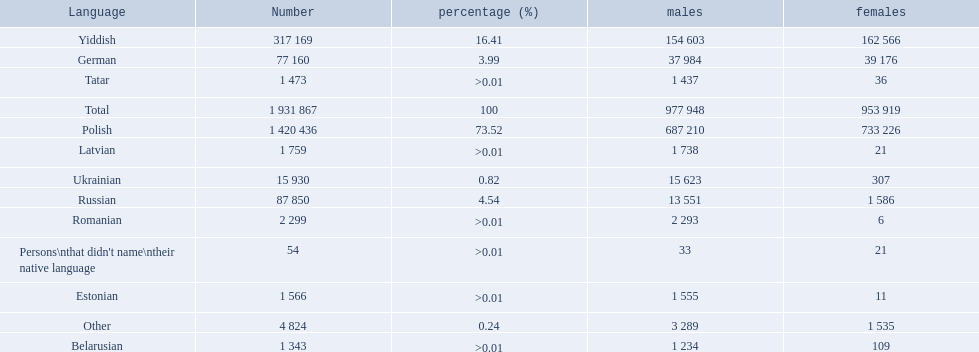Parse the full table in json format. {'header': ['Language', 'Number', 'percentage (%)', 'males', 'females'], 'rows': [['Yiddish', '317 169', '16.41', '154 603', '162 566'], ['German', '77 160', '3.99', '37 984', '39 176'], ['Tatar', '1 473', '>0.01', '1 437', '36'], ['Total', '1 931 867', '100', '977 948', '953 919'], ['Polish', '1 420 436', '73.52', '687 210', '733 226'], ['Latvian', '1 759', '>0.01', '1 738', '21'], ['Ukrainian', '15 930', '0.82', '15 623', '307'], ['Russian', '87 850', '4.54', '13 551', '1 586'], ['Romanian', '2 299', '>0.01', '2 293', '6'], ["Persons\\nthat didn't name\\ntheir native language", '54', '>0.01', '33', '21'], ['Estonian', '1 566', '>0.01', '1 555', '11'], ['Other', '4 824', '0.24', '3 289', '1 535'], ['Belarusian', '1 343', '>0.01', '1 234', '109']]} Which languages had percentages of >0.01? Romanian, Latvian, Estonian, Tatar, Belarusian. What was the top language? Romanian. 